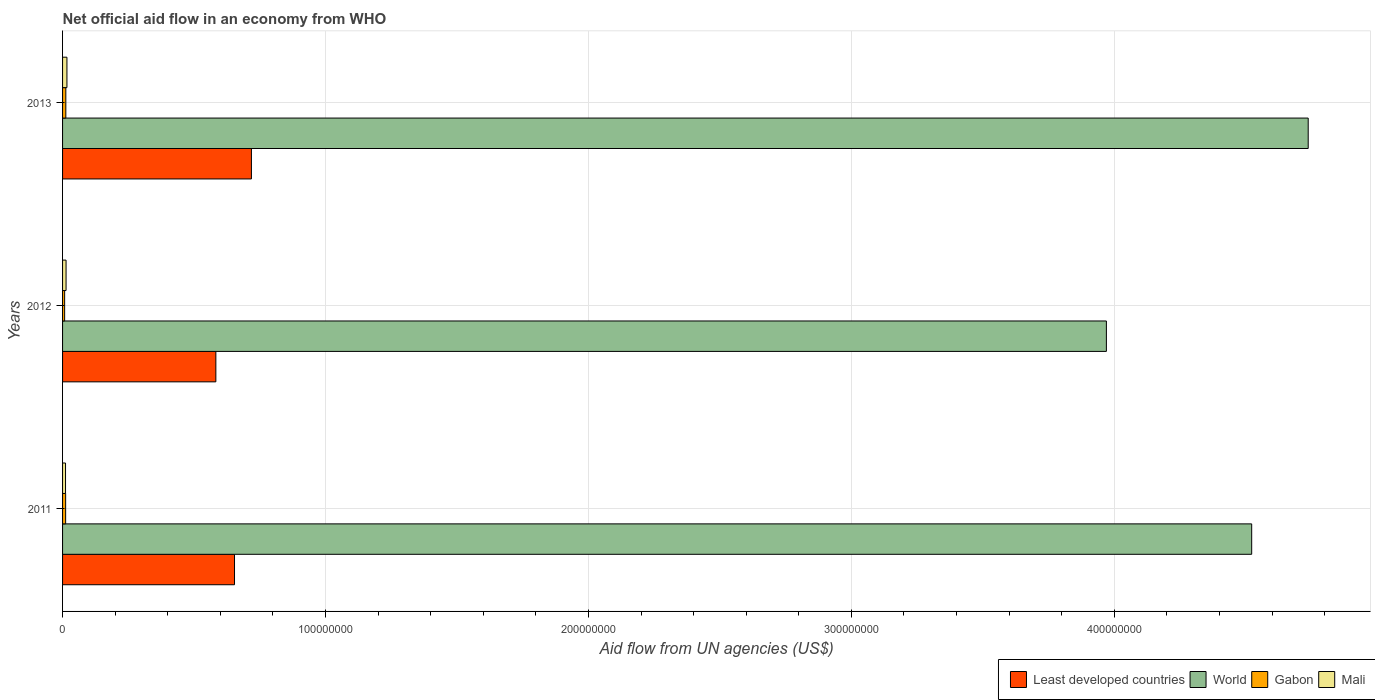How many bars are there on the 3rd tick from the bottom?
Your answer should be very brief. 4. What is the net official aid flow in World in 2011?
Provide a short and direct response. 4.52e+08. Across all years, what is the maximum net official aid flow in Gabon?
Your answer should be compact. 1.24e+06. Across all years, what is the minimum net official aid flow in World?
Keep it short and to the point. 3.97e+08. In which year was the net official aid flow in Mali maximum?
Your response must be concise. 2013. What is the total net official aid flow in Least developed countries in the graph?
Your answer should be very brief. 1.96e+08. What is the difference between the net official aid flow in Least developed countries in 2011 and that in 2012?
Your answer should be compact. 7.10e+06. What is the difference between the net official aid flow in World in 2011 and the net official aid flow in Mali in 2012?
Give a very brief answer. 4.51e+08. What is the average net official aid flow in Mali per year?
Ensure brevity in your answer.  1.37e+06. In the year 2011, what is the difference between the net official aid flow in World and net official aid flow in Least developed countries?
Your answer should be compact. 3.87e+08. What is the ratio of the net official aid flow in Gabon in 2012 to that in 2013?
Ensure brevity in your answer.  0.64. Is the difference between the net official aid flow in World in 2012 and 2013 greater than the difference between the net official aid flow in Least developed countries in 2012 and 2013?
Provide a succinct answer. No. What is the difference between the highest and the lowest net official aid flow in World?
Make the answer very short. 7.68e+07. In how many years, is the net official aid flow in Gabon greater than the average net official aid flow in Gabon taken over all years?
Ensure brevity in your answer.  2. Is the sum of the net official aid flow in Least developed countries in 2012 and 2013 greater than the maximum net official aid flow in World across all years?
Offer a terse response. No. What does the 3rd bar from the bottom in 2012 represents?
Ensure brevity in your answer.  Gabon. Is it the case that in every year, the sum of the net official aid flow in Mali and net official aid flow in World is greater than the net official aid flow in Least developed countries?
Ensure brevity in your answer.  Yes. How many bars are there?
Give a very brief answer. 12. Are all the bars in the graph horizontal?
Provide a succinct answer. Yes. How many years are there in the graph?
Your answer should be compact. 3. What is the difference between two consecutive major ticks on the X-axis?
Provide a succinct answer. 1.00e+08. Where does the legend appear in the graph?
Your answer should be compact. Bottom right. How are the legend labels stacked?
Offer a terse response. Horizontal. What is the title of the graph?
Your answer should be compact. Net official aid flow in an economy from WHO. Does "Portugal" appear as one of the legend labels in the graph?
Your answer should be compact. No. What is the label or title of the X-axis?
Offer a terse response. Aid flow from UN agencies (US$). What is the Aid flow from UN agencies (US$) in Least developed countries in 2011?
Your answer should be very brief. 6.54e+07. What is the Aid flow from UN agencies (US$) in World in 2011?
Offer a terse response. 4.52e+08. What is the Aid flow from UN agencies (US$) in Gabon in 2011?
Make the answer very short. 1.17e+06. What is the Aid flow from UN agencies (US$) of Mali in 2011?
Your answer should be compact. 1.13e+06. What is the Aid flow from UN agencies (US$) of Least developed countries in 2012?
Give a very brief answer. 5.83e+07. What is the Aid flow from UN agencies (US$) of World in 2012?
Make the answer very short. 3.97e+08. What is the Aid flow from UN agencies (US$) in Gabon in 2012?
Provide a succinct answer. 7.90e+05. What is the Aid flow from UN agencies (US$) in Mali in 2012?
Make the answer very short. 1.33e+06. What is the Aid flow from UN agencies (US$) of Least developed countries in 2013?
Provide a succinct answer. 7.18e+07. What is the Aid flow from UN agencies (US$) in World in 2013?
Your response must be concise. 4.74e+08. What is the Aid flow from UN agencies (US$) of Gabon in 2013?
Provide a succinct answer. 1.24e+06. What is the Aid flow from UN agencies (US$) in Mali in 2013?
Offer a terse response. 1.66e+06. Across all years, what is the maximum Aid flow from UN agencies (US$) of Least developed countries?
Keep it short and to the point. 7.18e+07. Across all years, what is the maximum Aid flow from UN agencies (US$) of World?
Provide a succinct answer. 4.74e+08. Across all years, what is the maximum Aid flow from UN agencies (US$) of Gabon?
Keep it short and to the point. 1.24e+06. Across all years, what is the maximum Aid flow from UN agencies (US$) of Mali?
Your answer should be compact. 1.66e+06. Across all years, what is the minimum Aid flow from UN agencies (US$) in Least developed countries?
Keep it short and to the point. 5.83e+07. Across all years, what is the minimum Aid flow from UN agencies (US$) in World?
Keep it short and to the point. 3.97e+08. Across all years, what is the minimum Aid flow from UN agencies (US$) of Gabon?
Your response must be concise. 7.90e+05. Across all years, what is the minimum Aid flow from UN agencies (US$) of Mali?
Keep it short and to the point. 1.13e+06. What is the total Aid flow from UN agencies (US$) in Least developed countries in the graph?
Offer a terse response. 1.96e+08. What is the total Aid flow from UN agencies (US$) of World in the graph?
Ensure brevity in your answer.  1.32e+09. What is the total Aid flow from UN agencies (US$) of Gabon in the graph?
Give a very brief answer. 3.20e+06. What is the total Aid flow from UN agencies (US$) of Mali in the graph?
Provide a succinct answer. 4.12e+06. What is the difference between the Aid flow from UN agencies (US$) of Least developed countries in 2011 and that in 2012?
Make the answer very short. 7.10e+06. What is the difference between the Aid flow from UN agencies (US$) of World in 2011 and that in 2012?
Offer a very short reply. 5.53e+07. What is the difference between the Aid flow from UN agencies (US$) in Gabon in 2011 and that in 2012?
Your answer should be very brief. 3.80e+05. What is the difference between the Aid flow from UN agencies (US$) of Least developed countries in 2011 and that in 2013?
Your response must be concise. -6.43e+06. What is the difference between the Aid flow from UN agencies (US$) in World in 2011 and that in 2013?
Offer a very short reply. -2.15e+07. What is the difference between the Aid flow from UN agencies (US$) of Gabon in 2011 and that in 2013?
Make the answer very short. -7.00e+04. What is the difference between the Aid flow from UN agencies (US$) of Mali in 2011 and that in 2013?
Provide a short and direct response. -5.30e+05. What is the difference between the Aid flow from UN agencies (US$) in Least developed countries in 2012 and that in 2013?
Ensure brevity in your answer.  -1.35e+07. What is the difference between the Aid flow from UN agencies (US$) in World in 2012 and that in 2013?
Give a very brief answer. -7.68e+07. What is the difference between the Aid flow from UN agencies (US$) in Gabon in 2012 and that in 2013?
Ensure brevity in your answer.  -4.50e+05. What is the difference between the Aid flow from UN agencies (US$) of Mali in 2012 and that in 2013?
Ensure brevity in your answer.  -3.30e+05. What is the difference between the Aid flow from UN agencies (US$) in Least developed countries in 2011 and the Aid flow from UN agencies (US$) in World in 2012?
Make the answer very short. -3.32e+08. What is the difference between the Aid flow from UN agencies (US$) in Least developed countries in 2011 and the Aid flow from UN agencies (US$) in Gabon in 2012?
Your answer should be compact. 6.46e+07. What is the difference between the Aid flow from UN agencies (US$) in Least developed countries in 2011 and the Aid flow from UN agencies (US$) in Mali in 2012?
Keep it short and to the point. 6.41e+07. What is the difference between the Aid flow from UN agencies (US$) of World in 2011 and the Aid flow from UN agencies (US$) of Gabon in 2012?
Make the answer very short. 4.51e+08. What is the difference between the Aid flow from UN agencies (US$) in World in 2011 and the Aid flow from UN agencies (US$) in Mali in 2012?
Your answer should be very brief. 4.51e+08. What is the difference between the Aid flow from UN agencies (US$) in Least developed countries in 2011 and the Aid flow from UN agencies (US$) in World in 2013?
Offer a very short reply. -4.08e+08. What is the difference between the Aid flow from UN agencies (US$) of Least developed countries in 2011 and the Aid flow from UN agencies (US$) of Gabon in 2013?
Ensure brevity in your answer.  6.42e+07. What is the difference between the Aid flow from UN agencies (US$) in Least developed countries in 2011 and the Aid flow from UN agencies (US$) in Mali in 2013?
Make the answer very short. 6.37e+07. What is the difference between the Aid flow from UN agencies (US$) in World in 2011 and the Aid flow from UN agencies (US$) in Gabon in 2013?
Ensure brevity in your answer.  4.51e+08. What is the difference between the Aid flow from UN agencies (US$) of World in 2011 and the Aid flow from UN agencies (US$) of Mali in 2013?
Provide a succinct answer. 4.51e+08. What is the difference between the Aid flow from UN agencies (US$) of Gabon in 2011 and the Aid flow from UN agencies (US$) of Mali in 2013?
Your answer should be very brief. -4.90e+05. What is the difference between the Aid flow from UN agencies (US$) in Least developed countries in 2012 and the Aid flow from UN agencies (US$) in World in 2013?
Your answer should be compact. -4.15e+08. What is the difference between the Aid flow from UN agencies (US$) of Least developed countries in 2012 and the Aid flow from UN agencies (US$) of Gabon in 2013?
Your response must be concise. 5.71e+07. What is the difference between the Aid flow from UN agencies (US$) in Least developed countries in 2012 and the Aid flow from UN agencies (US$) in Mali in 2013?
Make the answer very short. 5.66e+07. What is the difference between the Aid flow from UN agencies (US$) in World in 2012 and the Aid flow from UN agencies (US$) in Gabon in 2013?
Provide a short and direct response. 3.96e+08. What is the difference between the Aid flow from UN agencies (US$) in World in 2012 and the Aid flow from UN agencies (US$) in Mali in 2013?
Ensure brevity in your answer.  3.95e+08. What is the difference between the Aid flow from UN agencies (US$) of Gabon in 2012 and the Aid flow from UN agencies (US$) of Mali in 2013?
Keep it short and to the point. -8.70e+05. What is the average Aid flow from UN agencies (US$) in Least developed countries per year?
Your response must be concise. 6.52e+07. What is the average Aid flow from UN agencies (US$) in World per year?
Offer a terse response. 4.41e+08. What is the average Aid flow from UN agencies (US$) of Gabon per year?
Offer a very short reply. 1.07e+06. What is the average Aid flow from UN agencies (US$) in Mali per year?
Offer a terse response. 1.37e+06. In the year 2011, what is the difference between the Aid flow from UN agencies (US$) in Least developed countries and Aid flow from UN agencies (US$) in World?
Offer a terse response. -3.87e+08. In the year 2011, what is the difference between the Aid flow from UN agencies (US$) in Least developed countries and Aid flow from UN agencies (US$) in Gabon?
Your answer should be very brief. 6.42e+07. In the year 2011, what is the difference between the Aid flow from UN agencies (US$) of Least developed countries and Aid flow from UN agencies (US$) of Mali?
Offer a terse response. 6.43e+07. In the year 2011, what is the difference between the Aid flow from UN agencies (US$) in World and Aid flow from UN agencies (US$) in Gabon?
Provide a short and direct response. 4.51e+08. In the year 2011, what is the difference between the Aid flow from UN agencies (US$) in World and Aid flow from UN agencies (US$) in Mali?
Keep it short and to the point. 4.51e+08. In the year 2012, what is the difference between the Aid flow from UN agencies (US$) of Least developed countries and Aid flow from UN agencies (US$) of World?
Make the answer very short. -3.39e+08. In the year 2012, what is the difference between the Aid flow from UN agencies (US$) in Least developed countries and Aid flow from UN agencies (US$) in Gabon?
Offer a terse response. 5.75e+07. In the year 2012, what is the difference between the Aid flow from UN agencies (US$) in Least developed countries and Aid flow from UN agencies (US$) in Mali?
Give a very brief answer. 5.70e+07. In the year 2012, what is the difference between the Aid flow from UN agencies (US$) of World and Aid flow from UN agencies (US$) of Gabon?
Give a very brief answer. 3.96e+08. In the year 2012, what is the difference between the Aid flow from UN agencies (US$) in World and Aid flow from UN agencies (US$) in Mali?
Provide a short and direct response. 3.96e+08. In the year 2012, what is the difference between the Aid flow from UN agencies (US$) of Gabon and Aid flow from UN agencies (US$) of Mali?
Make the answer very short. -5.40e+05. In the year 2013, what is the difference between the Aid flow from UN agencies (US$) in Least developed countries and Aid flow from UN agencies (US$) in World?
Your response must be concise. -4.02e+08. In the year 2013, what is the difference between the Aid flow from UN agencies (US$) in Least developed countries and Aid flow from UN agencies (US$) in Gabon?
Provide a short and direct response. 7.06e+07. In the year 2013, what is the difference between the Aid flow from UN agencies (US$) of Least developed countries and Aid flow from UN agencies (US$) of Mali?
Ensure brevity in your answer.  7.02e+07. In the year 2013, what is the difference between the Aid flow from UN agencies (US$) in World and Aid flow from UN agencies (US$) in Gabon?
Keep it short and to the point. 4.73e+08. In the year 2013, what is the difference between the Aid flow from UN agencies (US$) of World and Aid flow from UN agencies (US$) of Mali?
Give a very brief answer. 4.72e+08. In the year 2013, what is the difference between the Aid flow from UN agencies (US$) in Gabon and Aid flow from UN agencies (US$) in Mali?
Provide a succinct answer. -4.20e+05. What is the ratio of the Aid flow from UN agencies (US$) of Least developed countries in 2011 to that in 2012?
Ensure brevity in your answer.  1.12. What is the ratio of the Aid flow from UN agencies (US$) of World in 2011 to that in 2012?
Provide a succinct answer. 1.14. What is the ratio of the Aid flow from UN agencies (US$) of Gabon in 2011 to that in 2012?
Offer a terse response. 1.48. What is the ratio of the Aid flow from UN agencies (US$) in Mali in 2011 to that in 2012?
Provide a short and direct response. 0.85. What is the ratio of the Aid flow from UN agencies (US$) of Least developed countries in 2011 to that in 2013?
Provide a short and direct response. 0.91. What is the ratio of the Aid flow from UN agencies (US$) of World in 2011 to that in 2013?
Ensure brevity in your answer.  0.95. What is the ratio of the Aid flow from UN agencies (US$) in Gabon in 2011 to that in 2013?
Your answer should be compact. 0.94. What is the ratio of the Aid flow from UN agencies (US$) of Mali in 2011 to that in 2013?
Provide a short and direct response. 0.68. What is the ratio of the Aid flow from UN agencies (US$) of Least developed countries in 2012 to that in 2013?
Ensure brevity in your answer.  0.81. What is the ratio of the Aid flow from UN agencies (US$) of World in 2012 to that in 2013?
Ensure brevity in your answer.  0.84. What is the ratio of the Aid flow from UN agencies (US$) of Gabon in 2012 to that in 2013?
Offer a terse response. 0.64. What is the ratio of the Aid flow from UN agencies (US$) in Mali in 2012 to that in 2013?
Your answer should be very brief. 0.8. What is the difference between the highest and the second highest Aid flow from UN agencies (US$) of Least developed countries?
Offer a terse response. 6.43e+06. What is the difference between the highest and the second highest Aid flow from UN agencies (US$) in World?
Your answer should be very brief. 2.15e+07. What is the difference between the highest and the second highest Aid flow from UN agencies (US$) in Mali?
Keep it short and to the point. 3.30e+05. What is the difference between the highest and the lowest Aid flow from UN agencies (US$) of Least developed countries?
Keep it short and to the point. 1.35e+07. What is the difference between the highest and the lowest Aid flow from UN agencies (US$) in World?
Offer a very short reply. 7.68e+07. What is the difference between the highest and the lowest Aid flow from UN agencies (US$) of Mali?
Your response must be concise. 5.30e+05. 